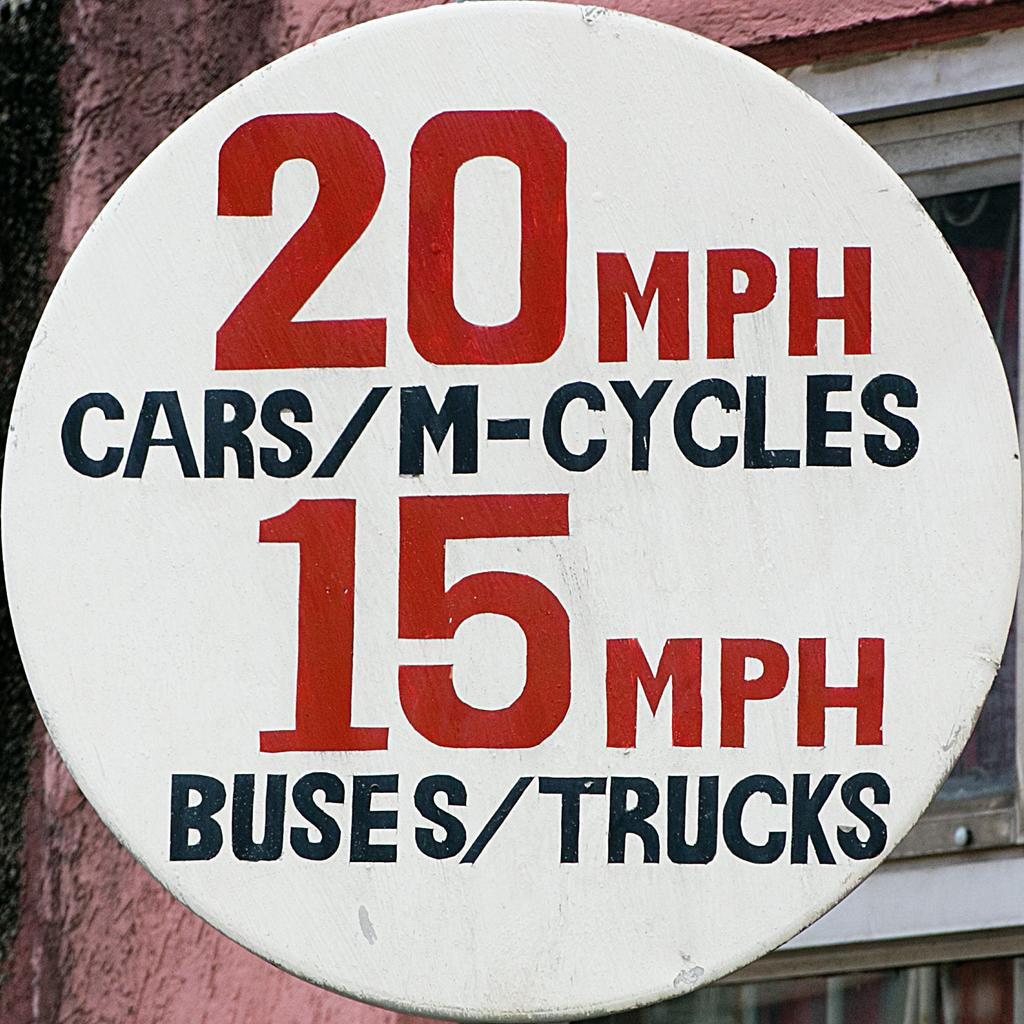<image>
Write a terse but informative summary of the picture. A large sign that shows the speed limits for cars and buses. 